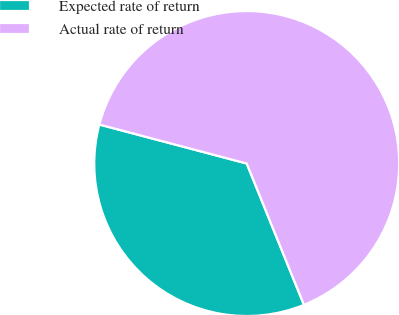Convert chart to OTSL. <chart><loc_0><loc_0><loc_500><loc_500><pie_chart><fcel>Expected rate of return<fcel>Actual rate of return<nl><fcel>35.24%<fcel>64.76%<nl></chart> 